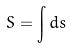<formula> <loc_0><loc_0><loc_500><loc_500>S = \int d s</formula> 